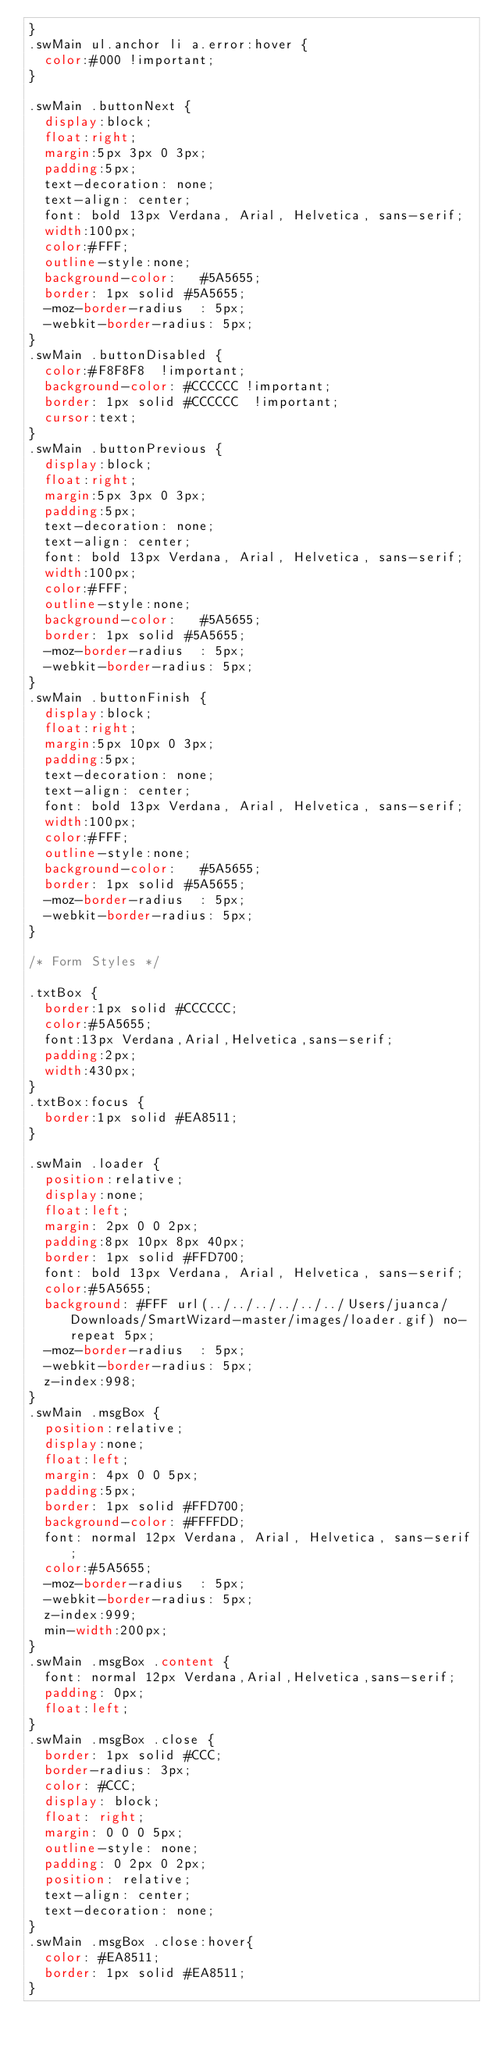<code> <loc_0><loc_0><loc_500><loc_500><_CSS_>}
.swMain ul.anchor li a.error:hover {
  color:#000 !important;       
}

.swMain .buttonNext {
  display:block;
  float:right;
  margin:5px 3px 0 3px;
  padding:5px;
  text-decoration: none;
  text-align: center;
  font: bold 13px Verdana, Arial, Helvetica, sans-serif;
  width:100px;
  color:#FFF;
  outline-style:none;
  background-color:   #5A5655;
  border: 1px solid #5A5655;
  -moz-border-radius  : 5px; 
  -webkit-border-radius: 5px;    
}
.swMain .buttonDisabled {
  color:#F8F8F8  !important;
  background-color: #CCCCCC !important;
  border: 1px solid #CCCCCC  !important;
  cursor:text;    
}
.swMain .buttonPrevious {
  display:block;
  float:right;
  margin:5px 3px 0 3px;
  padding:5px;
  text-decoration: none;
  text-align: center;
  font: bold 13px Verdana, Arial, Helvetica, sans-serif;
  width:100px;
  color:#FFF;
  outline-style:none;
  background-color:   #5A5655;
  border: 1px solid #5A5655;
  -moz-border-radius  : 5px; 
  -webkit-border-radius: 5px;    
}
.swMain .buttonFinish {
  display:block;
  float:right;
  margin:5px 10px 0 3px;
  padding:5px;
  text-decoration: none;
  text-align: center;
  font: bold 13px Verdana, Arial, Helvetica, sans-serif;
  width:100px;
  color:#FFF;
  outline-style:none;
  background-color:   #5A5655;
  border: 1px solid #5A5655;
  -moz-border-radius  : 5px; 
  -webkit-border-radius: 5px;    
}

/* Form Styles */

.txtBox {
  border:1px solid #CCCCCC;
  color:#5A5655;
  font:13px Verdana,Arial,Helvetica,sans-serif;
  padding:2px;
  width:430px;
}
.txtBox:focus {
  border:1px solid #EA8511;
}

.swMain .loader {
  position:relative;  
  display:none;
  float:left;  
  margin: 2px 0 0 2px;
  padding:8px 10px 8px 40px;
  border: 1px solid #FFD700; 
  font: bold 13px Verdana, Arial, Helvetica, sans-serif; 
  color:#5A5655;       
  background: #FFF url(../../../../../../Users/juanca/Downloads/SmartWizard-master/images/loader.gif) no-repeat 5px;
  -moz-border-radius  : 5px;
  -webkit-border-radius: 5px;
  z-index:998;
}
.swMain .msgBox {
  position:relative;  
  display:none;
  float:left;
  margin: 4px 0 0 5px;
  padding:5px;
  border: 1px solid #FFD700; 
  background-color: #FFFFDD;  
  font: normal 12px Verdana, Arial, Helvetica, sans-serif; 
  color:#5A5655;         
  -moz-border-radius  : 5px;
  -webkit-border-radius: 5px;
  z-index:999;
  min-width:200px;  
}
.swMain .msgBox .content {
  font: normal 12px Verdana,Arial,Helvetica,sans-serif;
  padding: 0px;
  float:left;
}
.swMain .msgBox .close {
  border: 1px solid #CCC;
  border-radius: 3px;
  color: #CCC;
  display: block;
  float: right;
  margin: 0 0 0 5px;
  outline-style: none;
  padding: 0 2px 0 2px;
  position: relative;
  text-align: center;
  text-decoration: none;
}
.swMain .msgBox .close:hover{
  color: #EA8511;
  border: 1px solid #EA8511;  
}</code> 